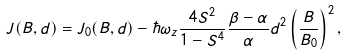Convert formula to latex. <formula><loc_0><loc_0><loc_500><loc_500>J ( B , d ) = J _ { 0 } ( B , d ) - \hbar { \omega } _ { z } \frac { 4 S ^ { 2 } } { 1 - S ^ { 4 } } \frac { \beta - \alpha } { \alpha } d ^ { 2 } \left ( \frac { B } { B _ { 0 } } \right ) ^ { 2 } ,</formula> 